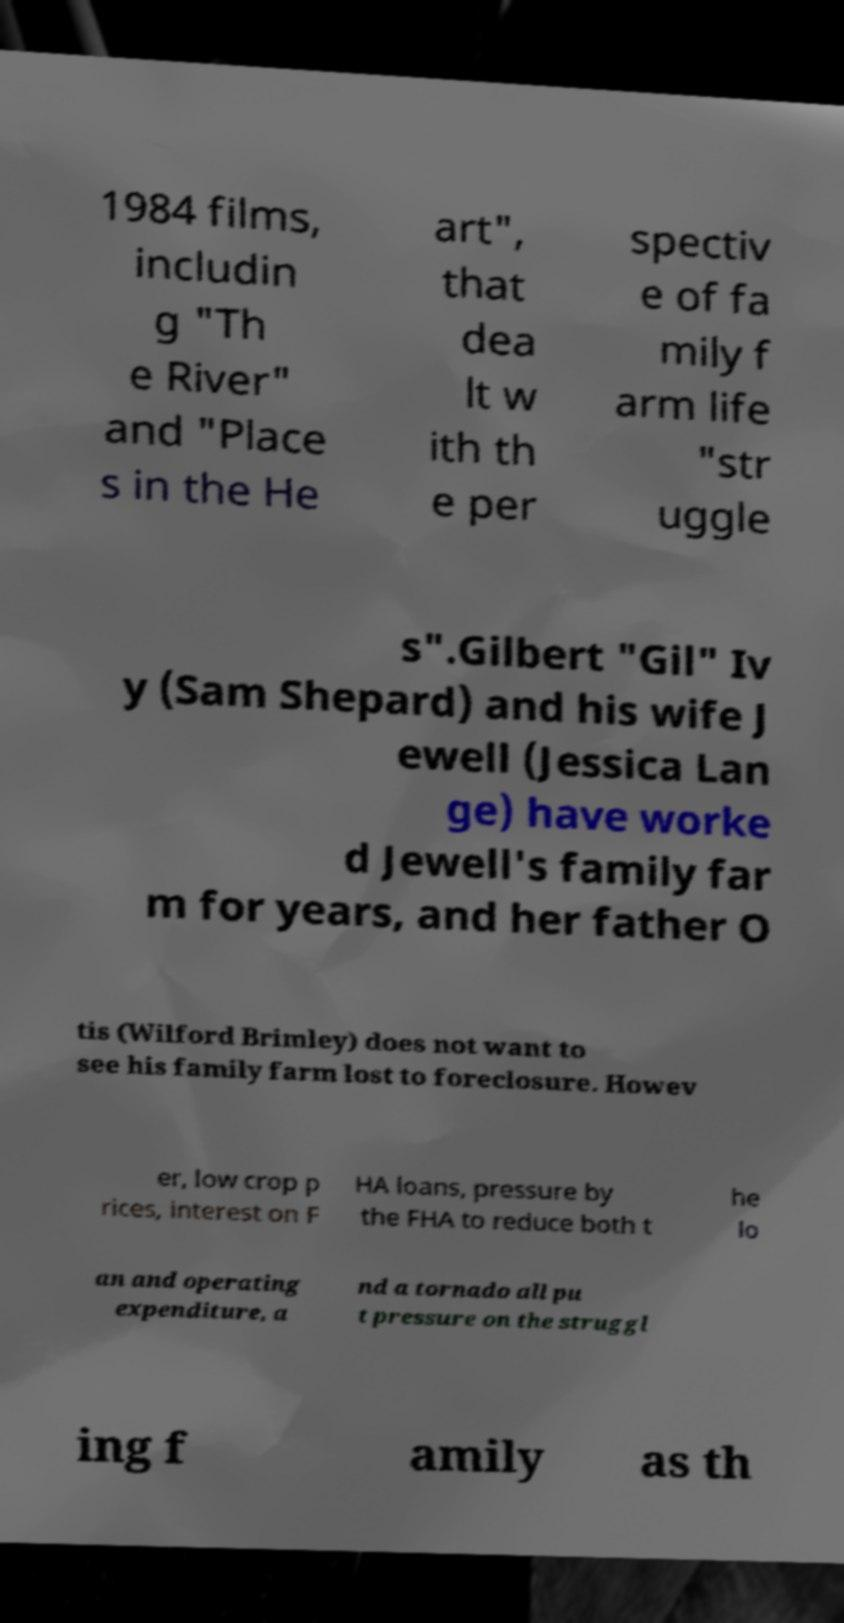Could you extract and type out the text from this image? 1984 films, includin g "Th e River" and "Place s in the He art", that dea lt w ith th e per spectiv e of fa mily f arm life "str uggle s".Gilbert "Gil" Iv y (Sam Shepard) and his wife J ewell (Jessica Lan ge) have worke d Jewell's family far m for years, and her father O tis (Wilford Brimley) does not want to see his family farm lost to foreclosure. Howev er, low crop p rices, interest on F HA loans, pressure by the FHA to reduce both t he lo an and operating expenditure, a nd a tornado all pu t pressure on the struggl ing f amily as th 